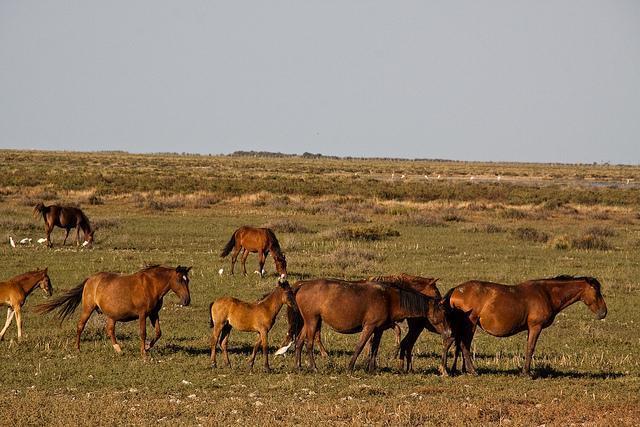How many horses are there?
Give a very brief answer. 8. How many horses are in the picture?
Give a very brief answer. 8. How many horses can be seen?
Give a very brief answer. 4. How many people are wearing red?
Give a very brief answer. 0. 